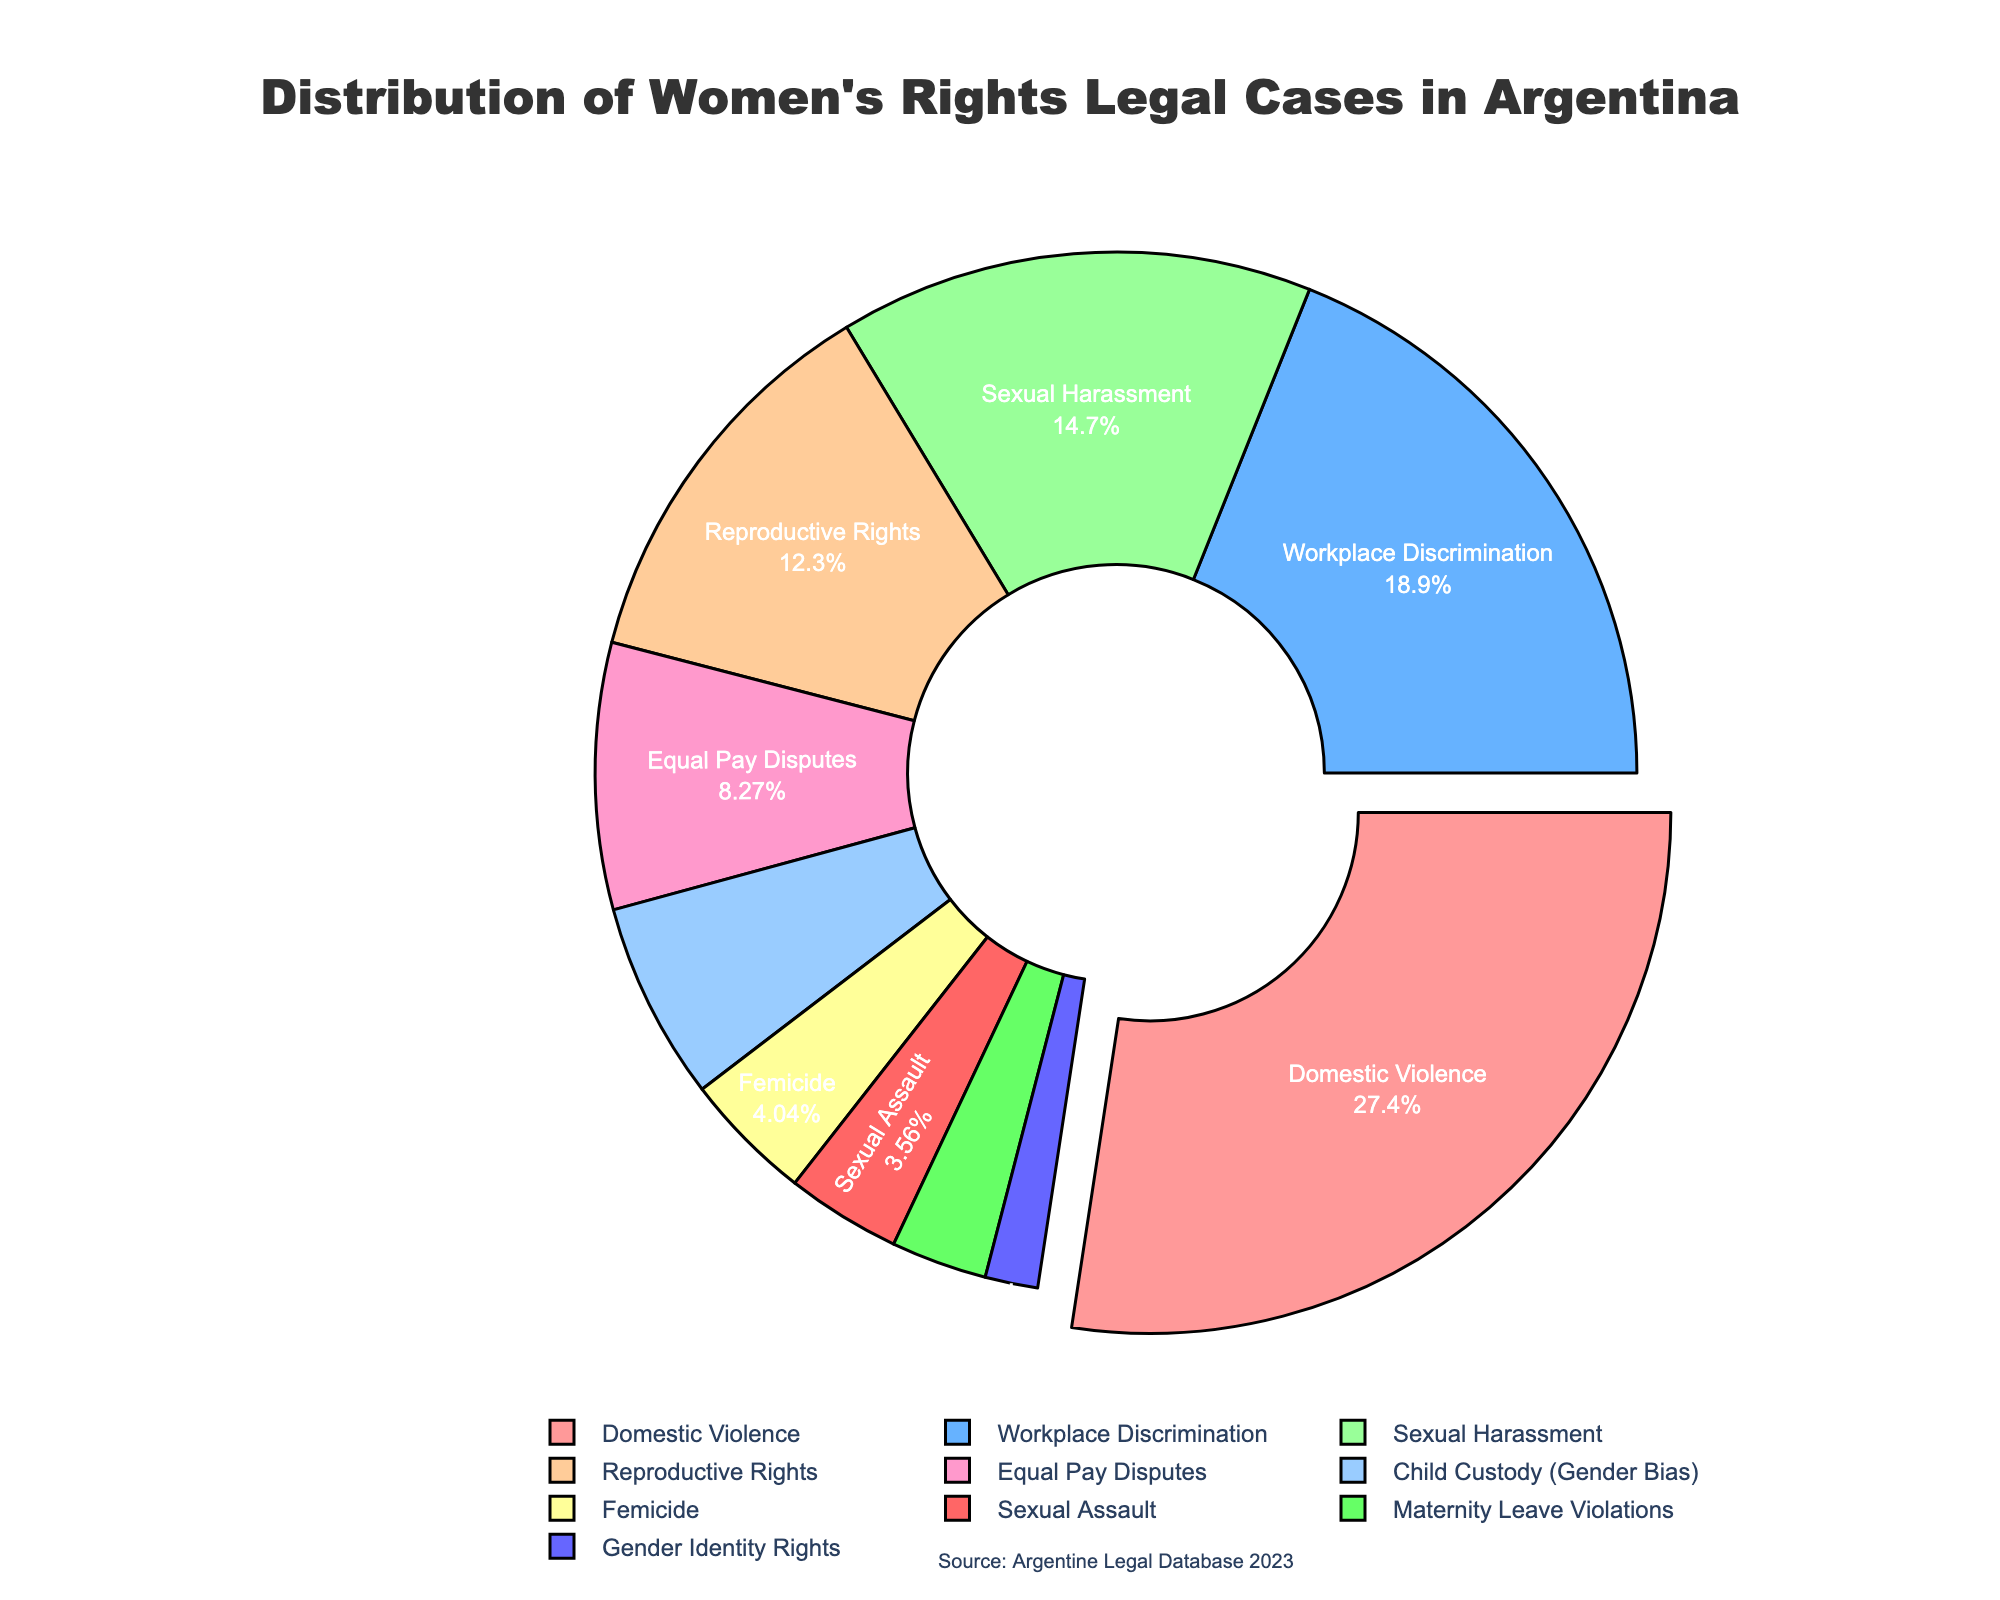What is the most common type of legal case related to women's rights in Argentina? The most common type is visually emphasized by being pulled out from the pie chart. It is also the largest segment.
Answer: Domestic Violence How much higher is the percentage of Domestic Violence cases compared to Femicide cases? The percentage for Domestic Violence is 28.5%, and for Femicide, it is 4.2%. The difference is calculated as 28.5% - 4.2%.
Answer: 24.3% Which category has a higher percentage of legal cases: Workplace Discrimination or Sexual Harassment? Comparing the segments for Workplace Discrimination (19.7%) and Sexual Harassment (15.3%), Workplace Discrimination is higher.
Answer: Workplace Discrimination If we sum the percentages of Reproductive Rights and Equal Pay Disputes, what is the total percentage? The percentage for Reproductive Rights is 12.8% and for Equal Pay Disputes is 8.6%. Adding them gives 12.8% + 8.6%.
Answer: 21.4% Between Sexual Harassment and Child Custody (Gender Bias), which has a smaller segment and by how much? Sexual Harassment is 15.3%, Child Custody (Gender Bias) is 6.4%. The difference is 15.3% - 6.4%.
Answer: Child Custody (Gender Bias), 8.9% What visual feature indicates the significance of the Domestic Violence category in the pie chart? The Domestic Violence segment is not only the largest but is also pulled out from the rest of the pie chart, emphasizing its significance.
Answer: It is pulled out and the largest segment What percentage of legal cases are related to Maternity Leave Violations and Gender Identity Rights combined? Maternity Leave Violations are 3.1% and Gender Identity Rights are 1.7%. Adding them gives 3.1% + 1.7%.
Answer: 4.8% What is the visual difference in color between the Equal Pay Disputes and Femicide categories? Equal Pay Disputes and Femicide are represented by different colors in the pie chart. Equal Pay Disputes appears in a pale yellow color, while Femicide is shown in a light red color.
Answer: Pale yellow for Equal Pay Disputes, light red for Femicide Are there more legal cases related to Sexual Assault or Maternity Leave Violations? Comparing the segments for Sexual Assault (3.7%) and Maternity Leave Violations (3.1%), Sexual Assault has a higher percentage.
Answer: Sexual Assault 